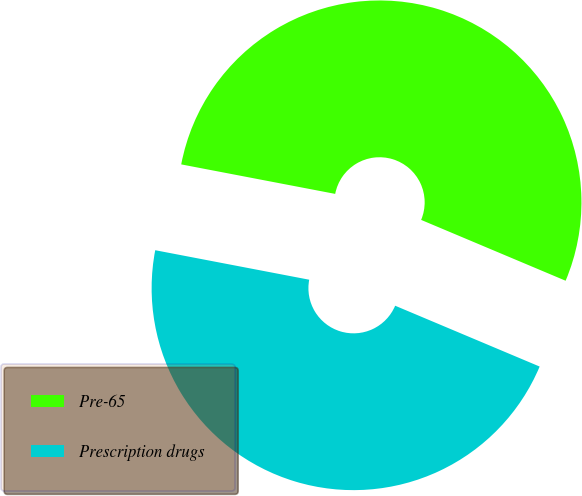<chart> <loc_0><loc_0><loc_500><loc_500><pie_chart><fcel>Pre-65<fcel>Prescription drugs<nl><fcel>53.33%<fcel>46.67%<nl></chart> 